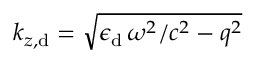<formula> <loc_0><loc_0><loc_500><loc_500>k _ { z , d } = \sqrt { \epsilon _ { d } \, \omega ^ { 2 } / c ^ { 2 } - q ^ { 2 } }</formula> 